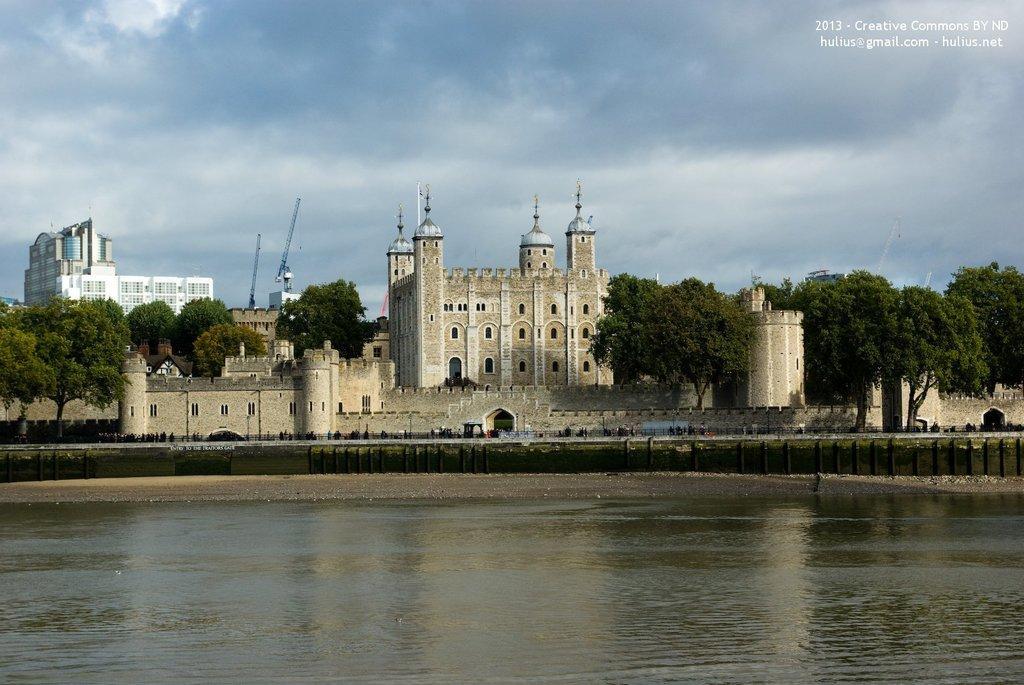How would you summarize this image in a sentence or two? In this picture we can see buildings, trees, water and in the background we can see sky with clouds. 